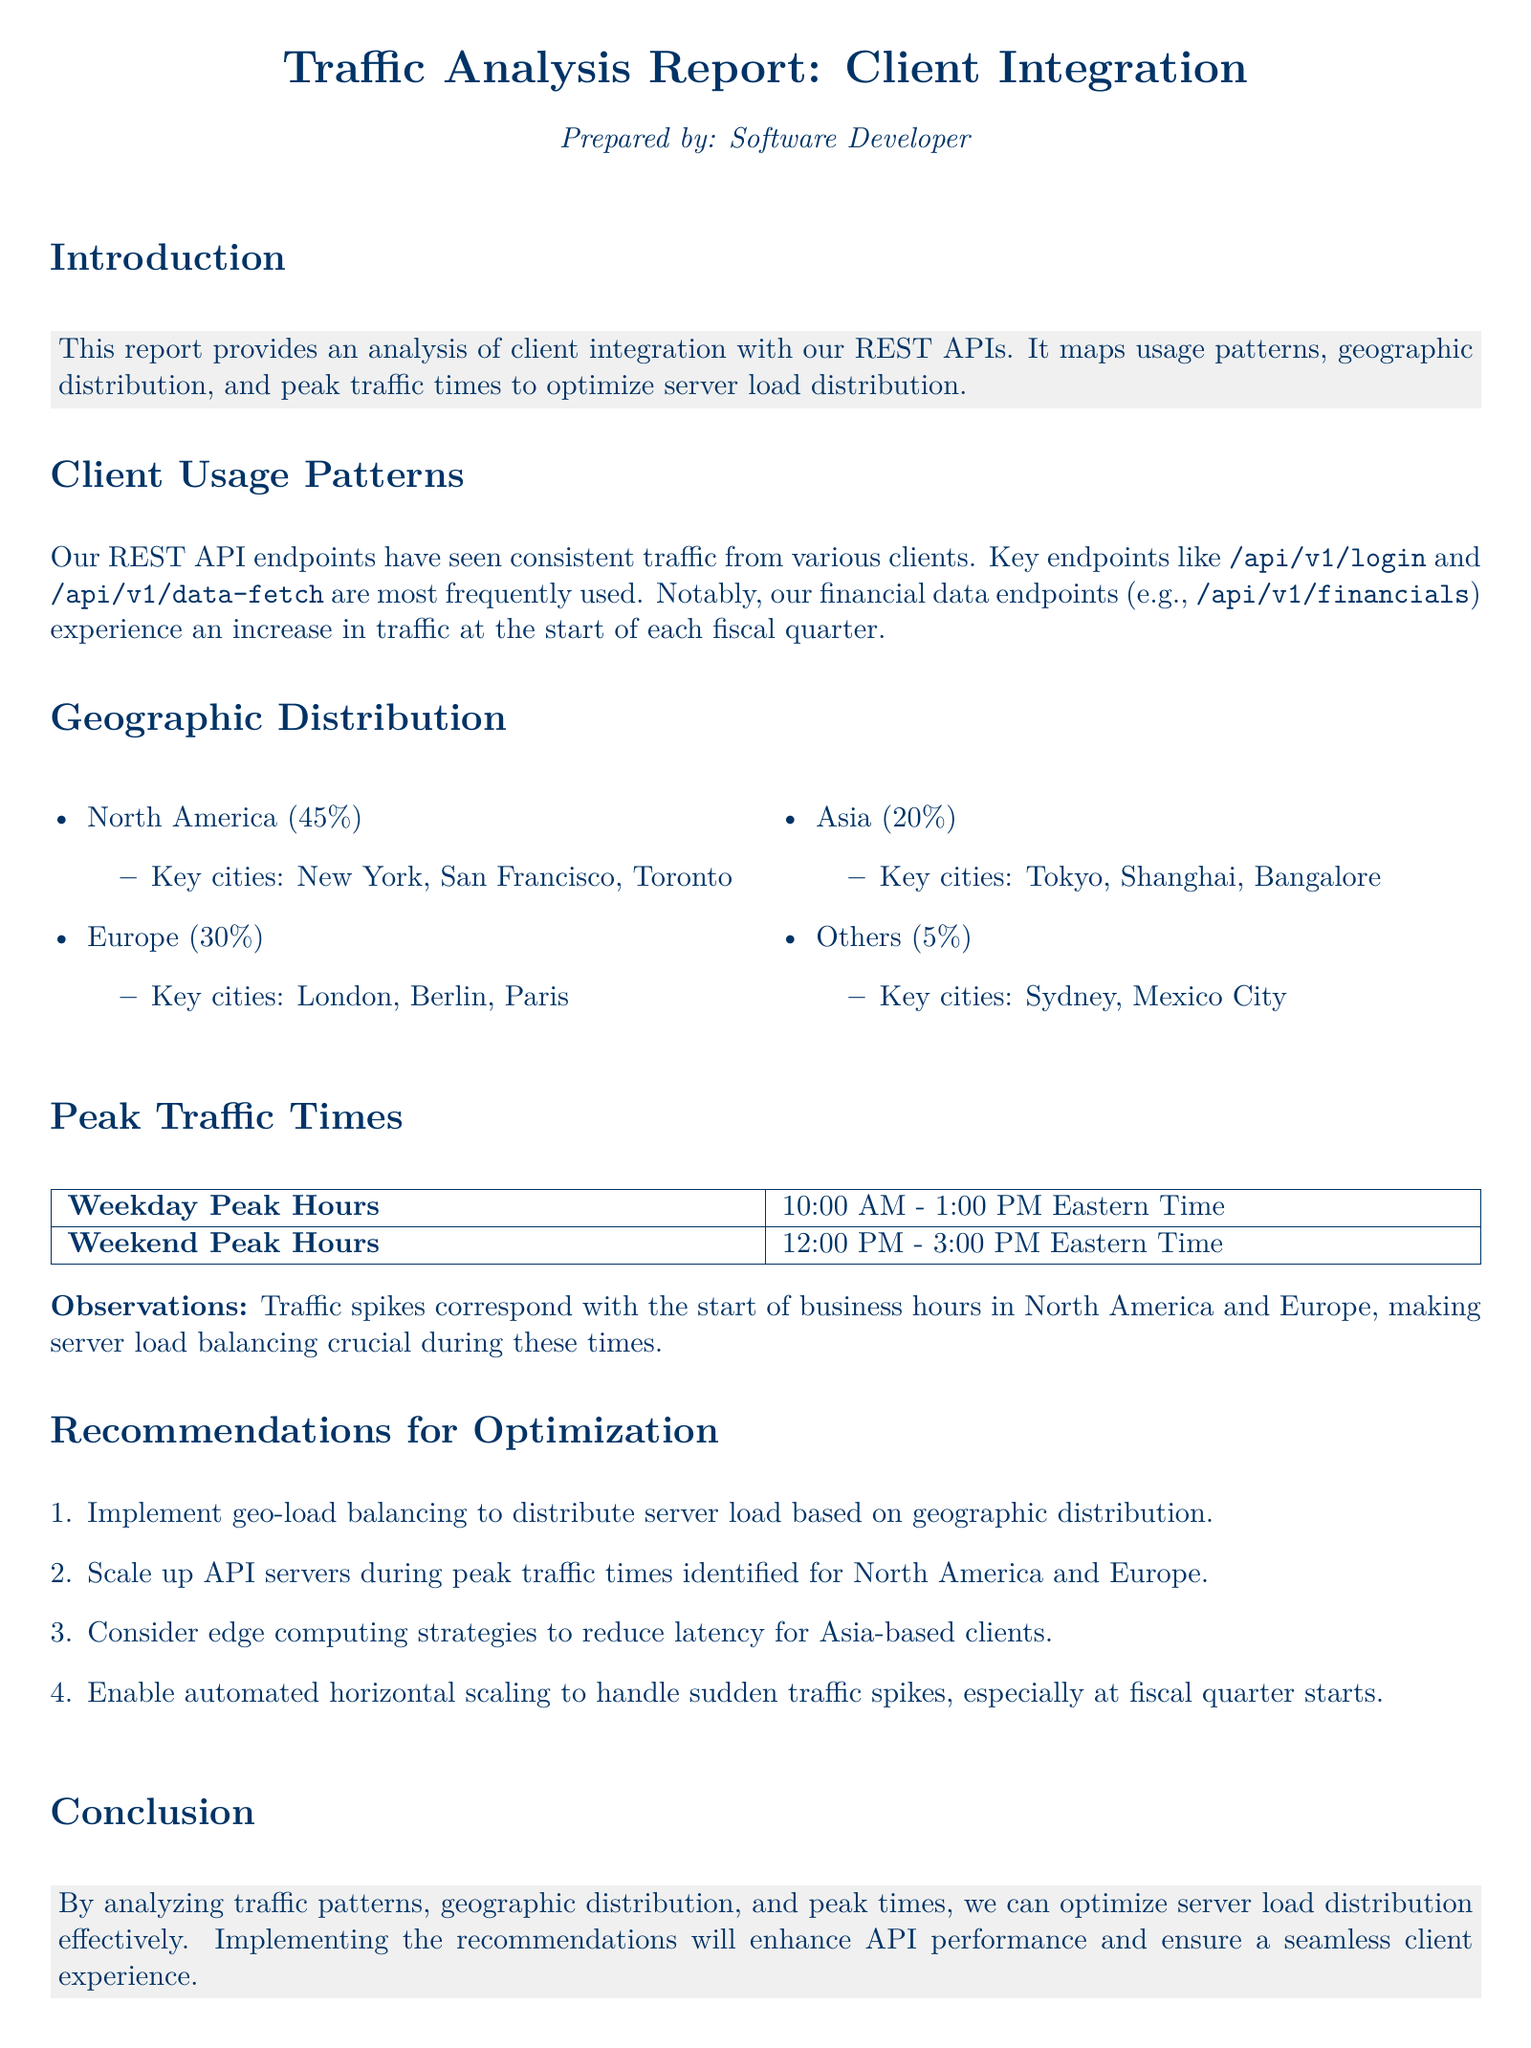What percentage of traffic comes from North America? The document states that North America accounts for 45% of the traffic.
Answer: 45% What are the key cities in Europe? The document lists London, Berlin, and Paris as key cities in Europe.
Answer: London, Berlin, Paris What is the peak traffic time on weekdays? The document specifies that the peak traffic hours on weekdays is from 10:00 AM to 1:00 PM Eastern Time.
Answer: 10:00 AM - 1:00 PM Eastern Time Which API endpoint sees an increase in traffic at the start of each fiscal quarter? The document indicates that the financial data endpoints experience increased traffic at the start of each fiscal quarter.
Answer: Financial data endpoints What recommendation involves reducing latency for Asia-based clients? The document recommends considering edge computing strategies to reduce latency for Asia-based clients.
Answer: Edge computing strategies What is the percentage of traffic from Asia? The document states that Asia accounts for 20% of the traffic.
Answer: 20% What time frame is considered peak on weekends? According to the document, peak traffic on weekends is from 12:00 PM to 3:00 PM Eastern Time.
Answer: 12:00 PM - 3:00 PM Eastern Time How should server load be balanced according to the recommendations? The document suggests implementing geo-load balancing to distribute server load based on geographic distribution.
Answer: Geo-load balancing What is a crucial factor during peak traffic times according to the observations? The document notes that server load balancing is crucial during peak traffic times.
Answer: Server load balancing 